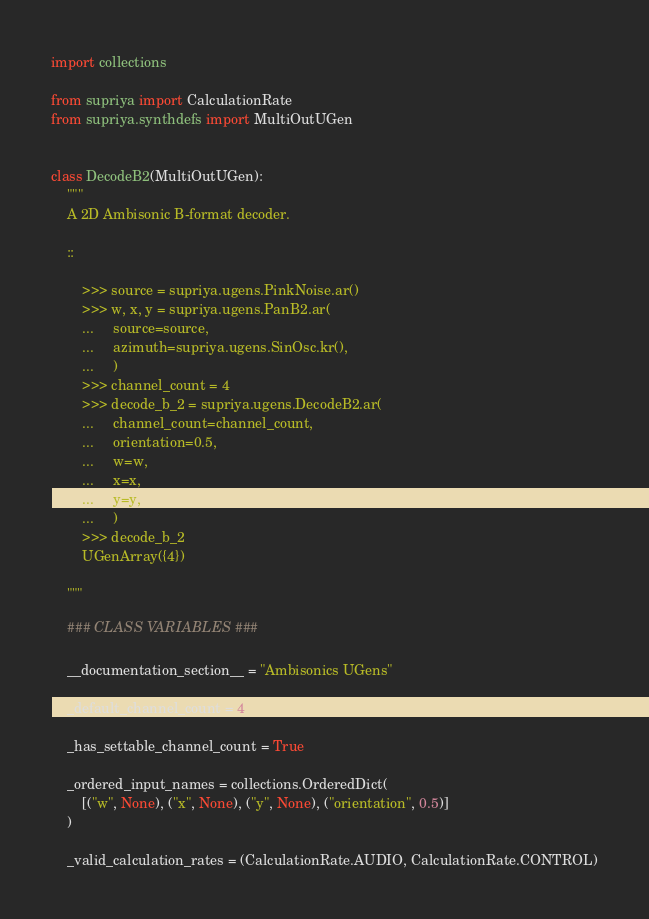Convert code to text. <code><loc_0><loc_0><loc_500><loc_500><_Python_>import collections

from supriya import CalculationRate
from supriya.synthdefs import MultiOutUGen


class DecodeB2(MultiOutUGen):
    """
    A 2D Ambisonic B-format decoder.

    ::

        >>> source = supriya.ugens.PinkNoise.ar()
        >>> w, x, y = supriya.ugens.PanB2.ar(
        ...     source=source,
        ...     azimuth=supriya.ugens.SinOsc.kr(),
        ...     )
        >>> channel_count = 4
        >>> decode_b_2 = supriya.ugens.DecodeB2.ar(
        ...     channel_count=channel_count,
        ...     orientation=0.5,
        ...     w=w,
        ...     x=x,
        ...     y=y,
        ...     )
        >>> decode_b_2
        UGenArray({4})

    """

    ### CLASS VARIABLES ###

    __documentation_section__ = "Ambisonics UGens"

    _default_channel_count = 4

    _has_settable_channel_count = True

    _ordered_input_names = collections.OrderedDict(
        [("w", None), ("x", None), ("y", None), ("orientation", 0.5)]
    )

    _valid_calculation_rates = (CalculationRate.AUDIO, CalculationRate.CONTROL)
</code> 